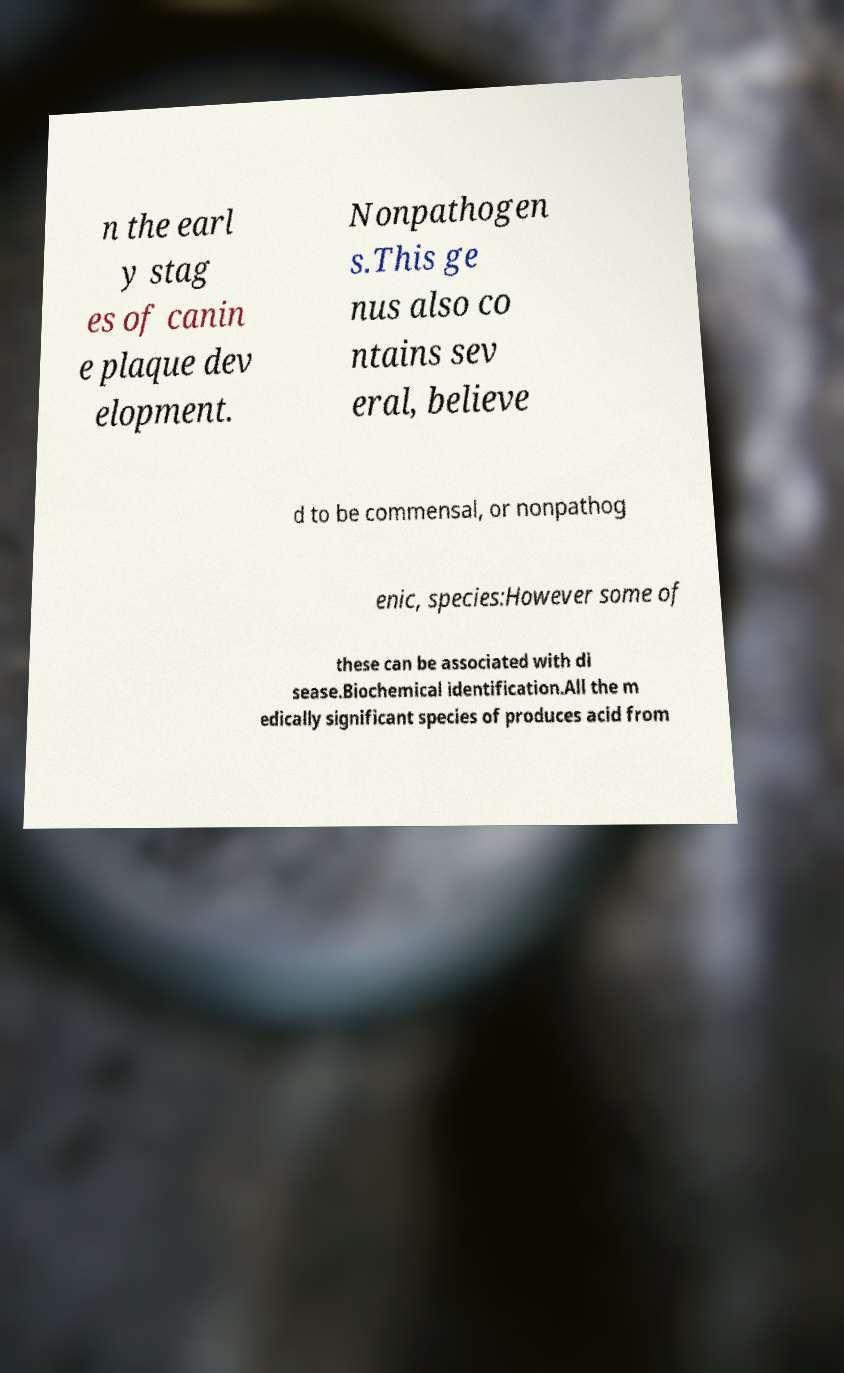Could you extract and type out the text from this image? n the earl y stag es of canin e plaque dev elopment. Nonpathogen s.This ge nus also co ntains sev eral, believe d to be commensal, or nonpathog enic, species:However some of these can be associated with di sease.Biochemical identification.All the m edically significant species of produces acid from 